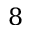<formula> <loc_0><loc_0><loc_500><loc_500>8</formula> 